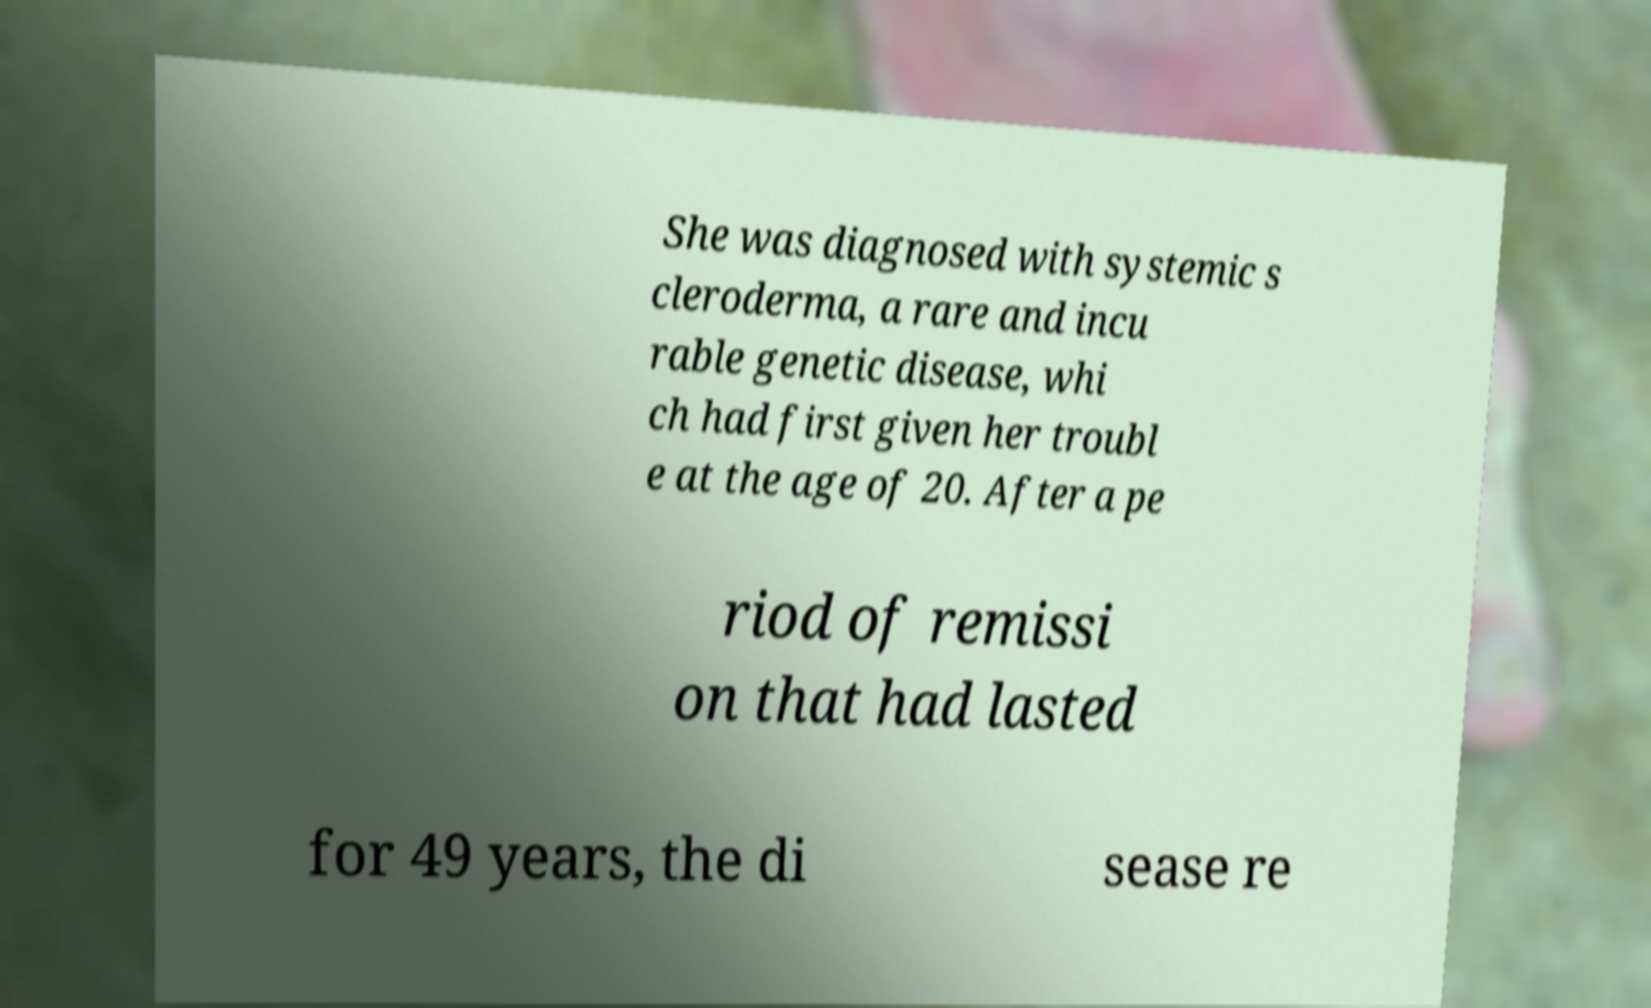Could you extract and type out the text from this image? She was diagnosed with systemic s cleroderma, a rare and incu rable genetic disease, whi ch had first given her troubl e at the age of 20. After a pe riod of remissi on that had lasted for 49 years, the di sease re 